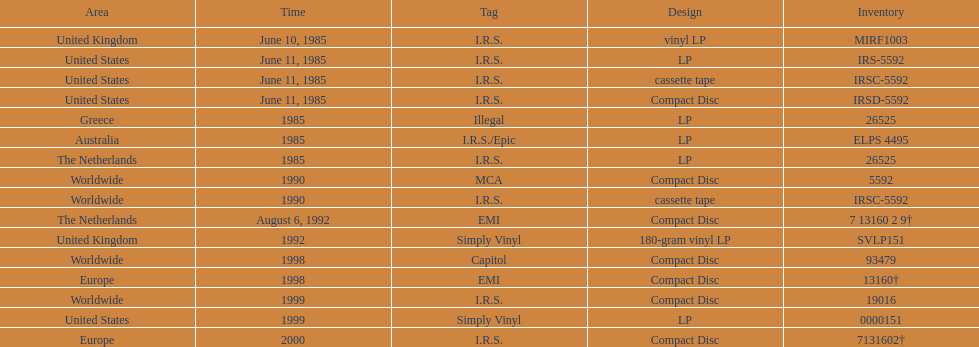What was the date of the initial vinyl lp launch? June 10, 1985. 